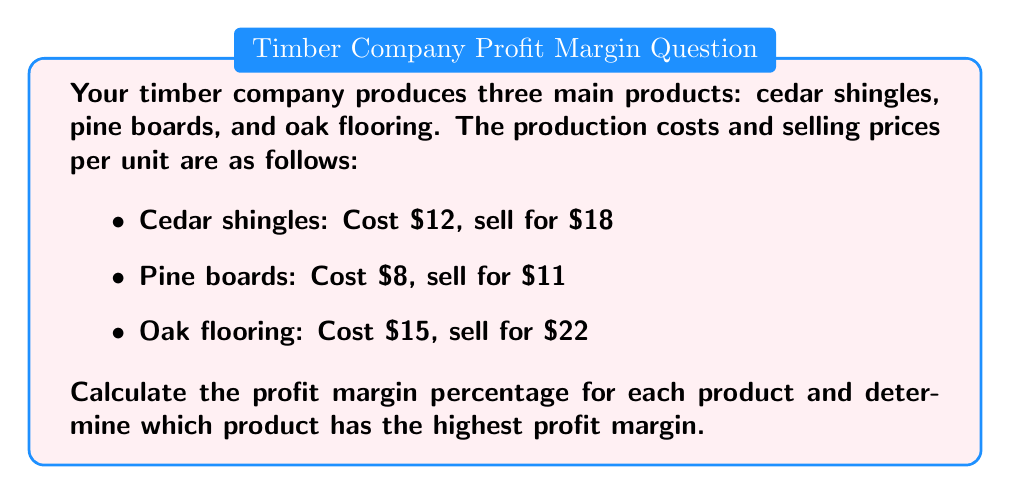Give your solution to this math problem. To calculate the profit margin percentage for each product, we'll use the formula:

$$ \text{Profit Margin} = \frac{\text{Selling Price} - \text{Cost}}{\text{Selling Price}} \times 100\% $$

1. Cedar shingles:
   $$ \text{Profit Margin} = \frac{18 - 12}{18} \times 100\% = \frac{6}{18} \times 100\% = 33.33\% $$

2. Pine boards:
   $$ \text{Profit Margin} = \frac{11 - 8}{11} \times 100\% = \frac{3}{11} \times 100\% \approx 27.27\% $$

3. Oak flooring:
   $$ \text{Profit Margin} = \frac{22 - 15}{22} \times 100\% = \frac{7}{22} \times 100\% \approx 31.82\% $$

Comparing the profit margins:
Cedar shingles: 33.33%
Pine boards: 27.27%
Oak flooring: 31.82%

The product with the highest profit margin is cedar shingles at 33.33%.
Answer: Cedar shingles: 33.33% 